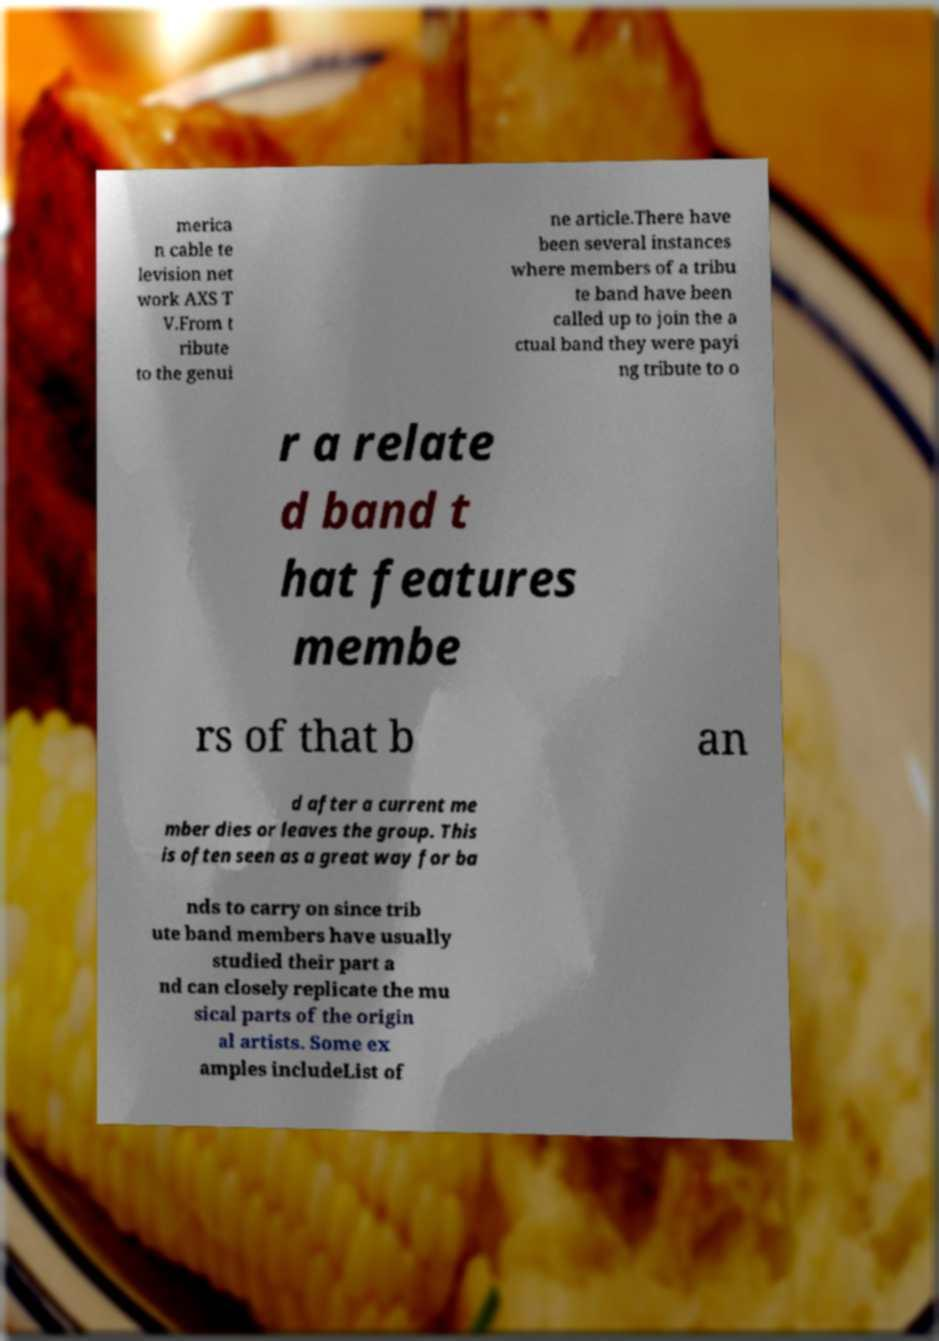Can you accurately transcribe the text from the provided image for me? merica n cable te levision net work AXS T V.From t ribute to the genui ne article.There have been several instances where members of a tribu te band have been called up to join the a ctual band they were payi ng tribute to o r a relate d band t hat features membe rs of that b an d after a current me mber dies or leaves the group. This is often seen as a great way for ba nds to carry on since trib ute band members have usually studied their part a nd can closely replicate the mu sical parts of the origin al artists. Some ex amples includeList of 